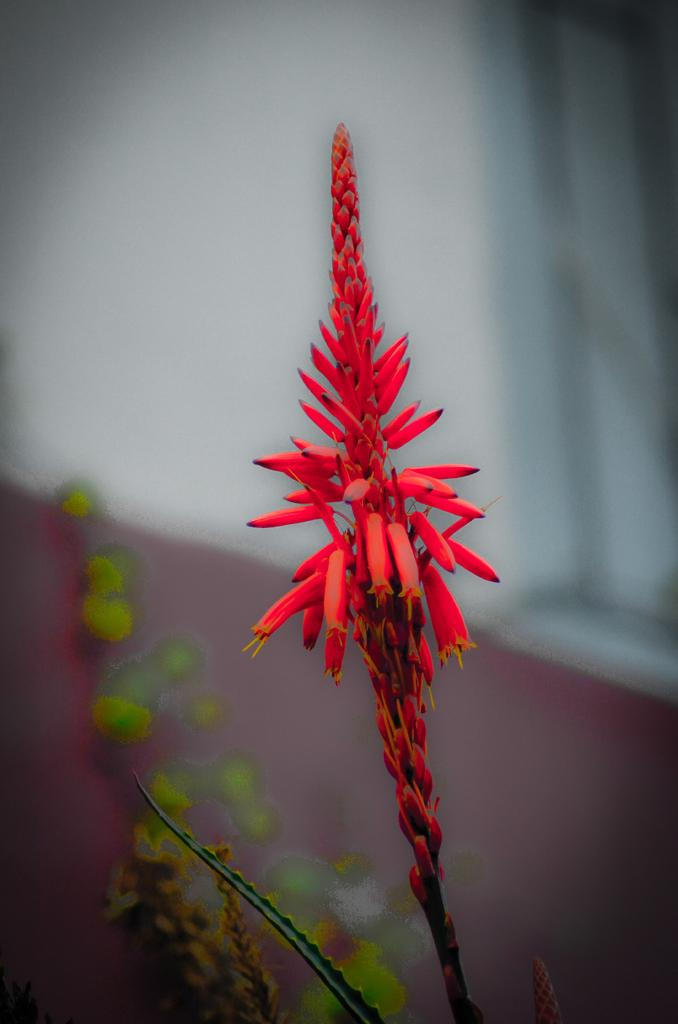What type of plants can be seen in the image? There are flowers in the image. What color are the flowers? The flowers are red in color. What else is present in the image besides the flowers? There are leaves in the image. What color are the leaves? The leaves are green in color. What type of cannon is present in the image? There is no cannon present in the image; it features flowers and leaves. What type of scene is depicted in the image? The image does not depict a scene; it simply shows flowers and leaves. 